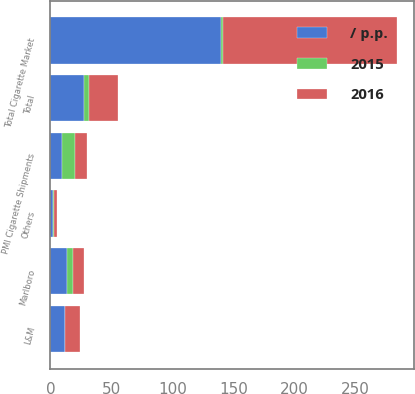Convert chart. <chart><loc_0><loc_0><loc_500><loc_500><stacked_bar_chart><ecel><fcel>Total Cigarette Market<fcel>PMI Cigarette Shipments<fcel>Marlboro<fcel>L&M<fcel>Others<fcel>Total<nl><fcel>2016<fcel>142.3<fcel>9.5<fcel>8.3<fcel>12.2<fcel>2.7<fcel>23.2<nl><fcel>/ p.p.<fcel>139.7<fcel>9.5<fcel>13.6<fcel>11.8<fcel>2.2<fcel>27.6<nl><fcel>2015<fcel>1.9<fcel>10.7<fcel>5.3<fcel>0.4<fcel>0.5<fcel>4.4<nl></chart> 